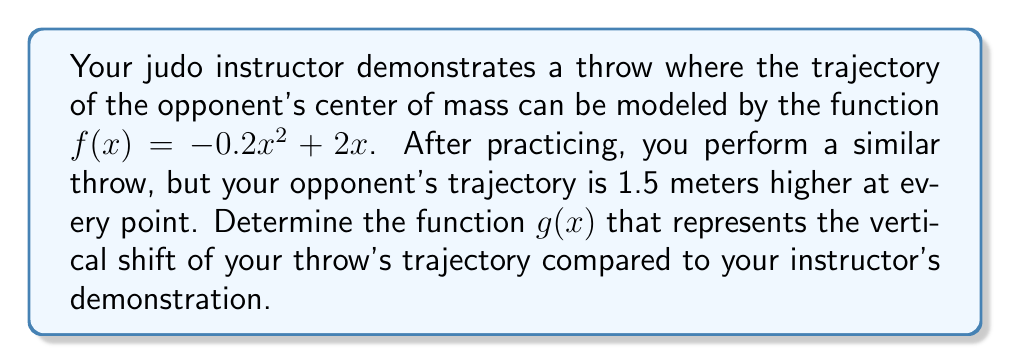Solve this math problem. To solve this problem, we need to understand vertical shifts in functions:

1) A vertical shift of a function $f(x)$ by $k$ units upward is represented by $f(x) + k$.

2) In this case, your throw's trajectory is 1.5 meters higher at every point, so we need to shift the original function upward by 1.5 units.

3) The original function is $f(x) = -0.2x^2 + 2x$.

4) To shift this function 1.5 units upward, we add 1.5 to the function:

   $g(x) = f(x) + 1.5$

5) Substituting the original function:

   $g(x) = (-0.2x^2 + 2x) + 1.5$

6) Simplifying:

   $g(x) = -0.2x^2 + 2x + 1.5$

This new function $g(x)$ represents your throw's trajectory, which is vertically shifted 1.5 meters higher than your instructor's demonstration at every point.
Answer: $g(x) = -0.2x^2 + 2x + 1.5$ 